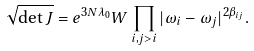Convert formula to latex. <formula><loc_0><loc_0><loc_500><loc_500>\sqrt { \det J } = e ^ { 3 N \lambda _ { 0 } } W \prod _ { i , j > i } | \omega _ { i } - \omega _ { j } | ^ { 2 \beta _ { i j } } .</formula> 